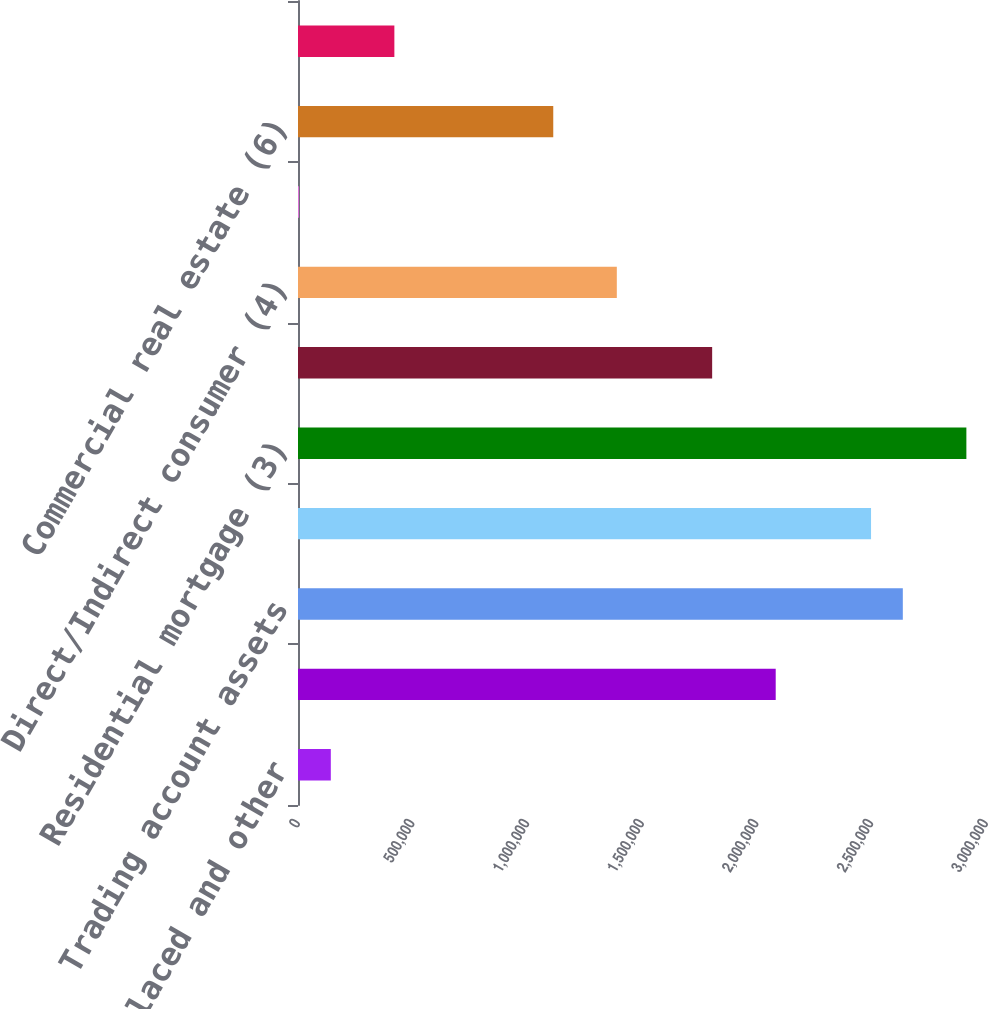Convert chart to OTSL. <chart><loc_0><loc_0><loc_500><loc_500><bar_chart><fcel>Time deposits placed and other<fcel>Federal funds sold and<fcel>Trading account assets<fcel>Debt securities (1)<fcel>Residential mortgage (3)<fcel>Home equity<fcel>Direct/Indirect consumer (4)<fcel>Other consumer (5)<fcel>Commercial real estate (6)<fcel>Commercial lease financing<nl><fcel>143078<fcel>2.08303e+06<fcel>2.63731e+06<fcel>2.49874e+06<fcel>2.91444e+06<fcel>1.8059e+06<fcel>1.39019e+06<fcel>4510<fcel>1.11306e+06<fcel>420215<nl></chart> 